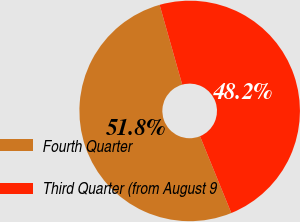<chart> <loc_0><loc_0><loc_500><loc_500><pie_chart><fcel>Fourth Quarter<fcel>Third Quarter (from August 9<nl><fcel>51.77%<fcel>48.23%<nl></chart> 